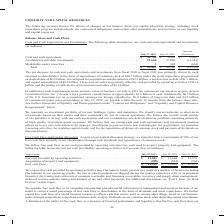From Cisco Systems's financial document, Which years does the table provide information for  cash and cash equivalents and investments? The document shows two values: 2019 and 2018. From the document: "July 27, 2019 July 28, 2018 Increase (Decrease) Cash and cash equivalents. . $ 11,750 $ 8,934 $ 2,816 Available-f July 27, 2019 July 28, 2018 Increase..." Also, How are the company's investments classified as short-term? based on their nature and their availability for use in current operations.. The document states: "classify our investments as short-term investments based on their nature and their availability for use in current operations. We believe the overall ..." Also, What was the increase (decrease) in available-for-sale debt investments? According to the financial document, (15,349) (in millions). The relevant text states: "ailable-for-sale debt investments. . 21,660 37,009 (15,349) Marketable equity securities . 3 605 (602) Total . $ 33,413 $ 46,548 $ (13,135)..." Also, can you calculate: What was the difference between cash and cash equivalents and Available-for-sale debt investments in 2019? Based on the calculation: 21,660-11,750, the result is 9910 (in millions). This is based on the information: "ncrease (Decrease) Cash and cash equivalents. . $ 11,750 $ 8,934 $ 2,816 Available-for-sale debt investments. . 21,660 37,009 (15,349) Marketable equity sec 34 $ 2,816 Available-for-sale debt investme..." The key data points involved are: 11,750, 21,660. Also, How many years did Marketable equity securities exceed $500 million?  Based on the analysis, there are 1 instances. The counting process: 2018. Also, can you calculate: What was the percentage change in the total between 2018 and 2019? To answer this question, I need to perform calculations using the financial data. The calculation is: (33,413-46,548)/46,548, which equals -28.22 (percentage). This is based on the information: "ketable equity securities . 3 605 (602) Total . $ 33,413 $ 46,548 $ (13,135) quity securities . 3 605 (602) Total . $ 33,413 $ 46,548 $ (13,135)..." The key data points involved are: 33,413, 46,548. 